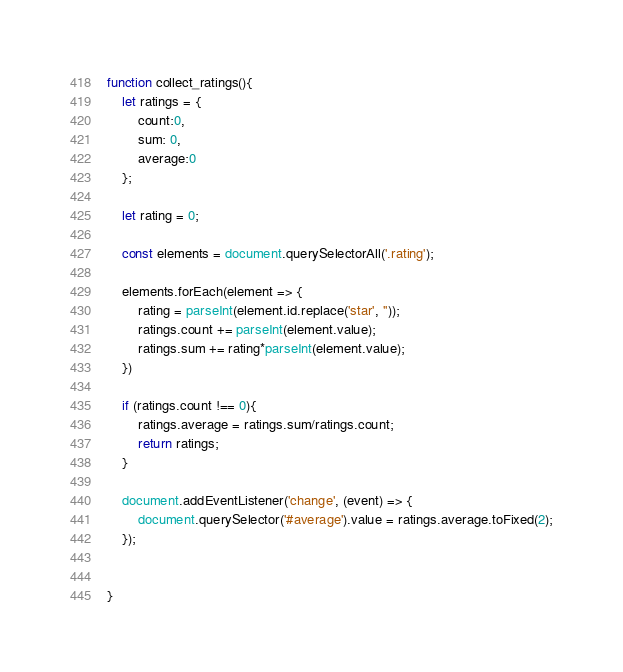Convert code to text. <code><loc_0><loc_0><loc_500><loc_500><_JavaScript_>function collect_ratings(){
    let ratings = {
        count:0, 
        sum: 0, 
        average:0
    };

    let rating = 0;

    const elements = document.querySelectorAll('.rating');

    elements.forEach(element => {
        rating = parseInt(element.id.replace('star', ''));
        ratings.count += parseInt(element.value);
        ratings.sum += rating*parseInt(element.value);
    })

    if (ratings.count !== 0){
        ratings.average = ratings.sum/ratings.count;   
        return ratings; 
    }
    
    document.addEventListener('change', (event) => {
        document.querySelector('#average').value = ratings.average.toFixed(2);
    });
    

}</code> 